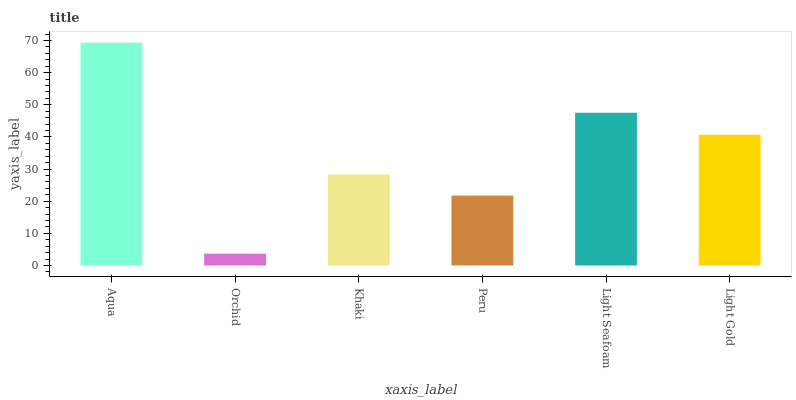Is Orchid the minimum?
Answer yes or no. Yes. Is Aqua the maximum?
Answer yes or no. Yes. Is Khaki the minimum?
Answer yes or no. No. Is Khaki the maximum?
Answer yes or no. No. Is Khaki greater than Orchid?
Answer yes or no. Yes. Is Orchid less than Khaki?
Answer yes or no. Yes. Is Orchid greater than Khaki?
Answer yes or no. No. Is Khaki less than Orchid?
Answer yes or no. No. Is Light Gold the high median?
Answer yes or no. Yes. Is Khaki the low median?
Answer yes or no. Yes. Is Orchid the high median?
Answer yes or no. No. Is Aqua the low median?
Answer yes or no. No. 